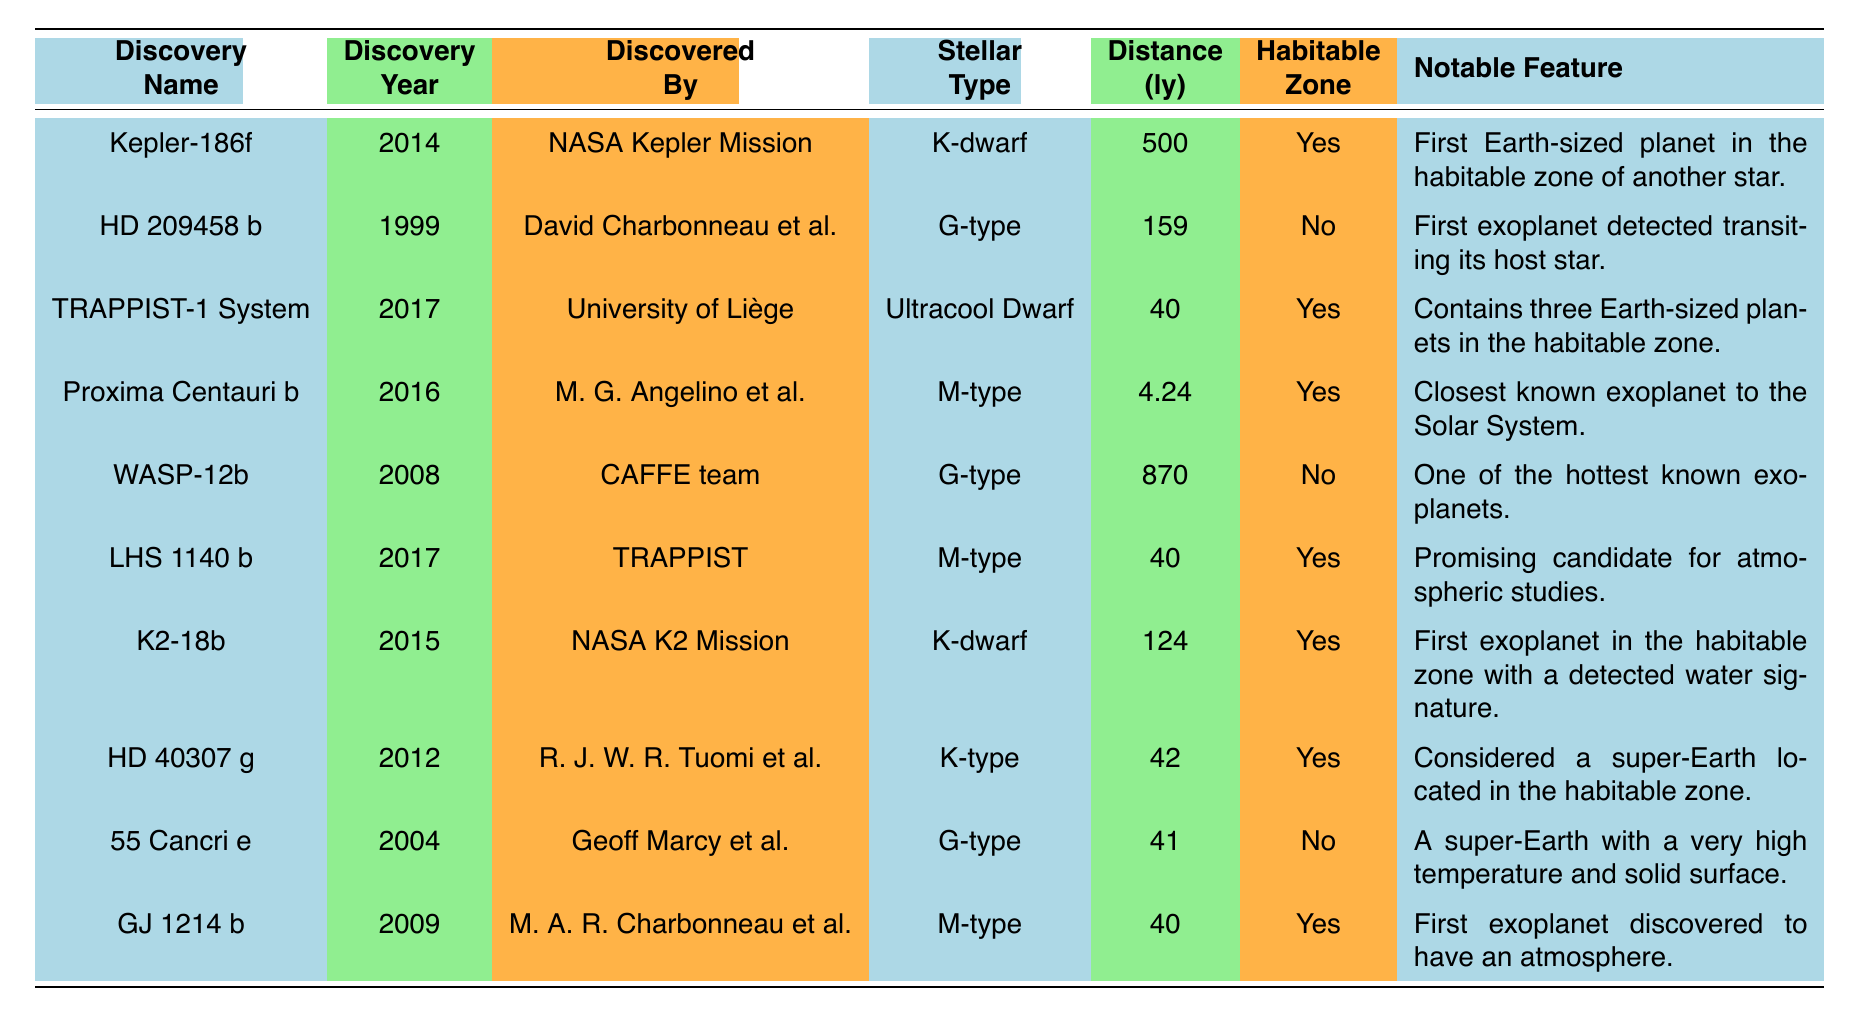What is the discovery year of Proxima Centauri b? To find the answer, we look at the row corresponding to Proxima Centauri b in the table, which shows that it was discovered in 2016.
Answer: 2016 Which exoplanet was discovered first, HD 209458 b or 55 Cancri e? In the table, HD 209458 b is listed with the discovery year 1999, while 55 Cancri e is listed with the discovery year 2004. Since 1999 is earlier than 2004, HD 209458 b was discovered first.
Answer: HD 209458 b How many exoplanets in the table are located within the habitable zone? By examining the 'Habitable Zone' column in the table, we note that there are 6 exoplanets marked as "Yes" for being within the habitable zone (Kepler-186f, TRAPPIST-1 System, Proxima Centauri b, LHS 1140 b, K2-18b, and HD 40307 g).
Answer: 6 What is the average distance of the exoplanets listed in light-years? To calculate the average distance, we sum the distances (500 + 159 + 40 + 4.24 + 870 + 40 + 124 + 42 + 41 + 40) = 1860.24 light-years. Then, divide by the number of exoplanets (10) to get the average: 1860.24/10 = 186.024 light-years.
Answer: Approximately 186.02 Is K2-18b notable for having a detected water signature? According to the notable features listed in the table, K2-18b is noted as the "First exoplanet in the habitable zone with a detected water signature," which confirms that it is indeed notable for this characteristic.
Answer: Yes How many of the discovered exoplanets belong to G-type stellar types? By reviewing the 'Stellar Type' column, we identify that there are 3 G-type exoplanets in the table (HD 209458 b, WASP-12b, and 55 Cancri e), confirming that three belong to the G-type.
Answer: 3 Which exoplanet has the notable feature of being the closest to the Solar System? The table states that Proxima Centauri b has the notable feature of being the "Closest known exoplanet to the Solar System," making it the exoplanet with this distinction.
Answer: Proxima Centauri b What is the distance in light-years of the TRAPPIST-1 system? The table indicates that the TRAPPIST-1 System is located at a distance of 40 light-years, as noted in the 'Distance (ly)' column.
Answer: 40 Which exoplanet was discovered by the NASA K2 Mission? Checking the 'Discovered By' column, we see that K2-18b is the exoplanet discovered by the NASA K2 Mission, according to the data in the table.
Answer: K2-18b 